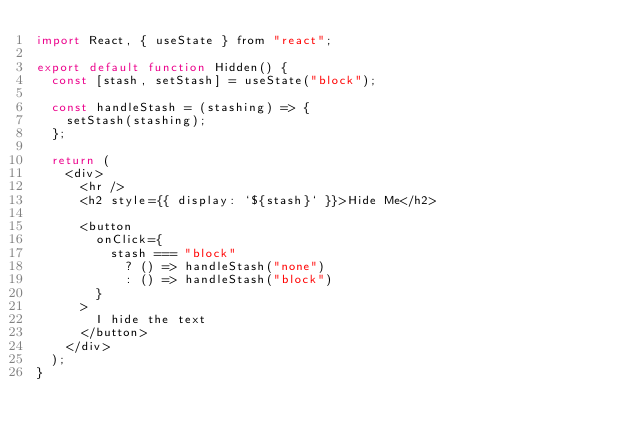Convert code to text. <code><loc_0><loc_0><loc_500><loc_500><_JavaScript_>import React, { useState } from "react";

export default function Hidden() {
  const [stash, setStash] = useState("block");

  const handleStash = (stashing) => {
    setStash(stashing);
  };

  return (
    <div>
      <hr />
      <h2 style={{ display: `${stash}` }}>Hide Me</h2>

      <button
        onClick={
          stash === "block"
            ? () => handleStash("none")
            : () => handleStash("block")
        }
      >
        I hide the text
      </button>
    </div>
  );
}
</code> 